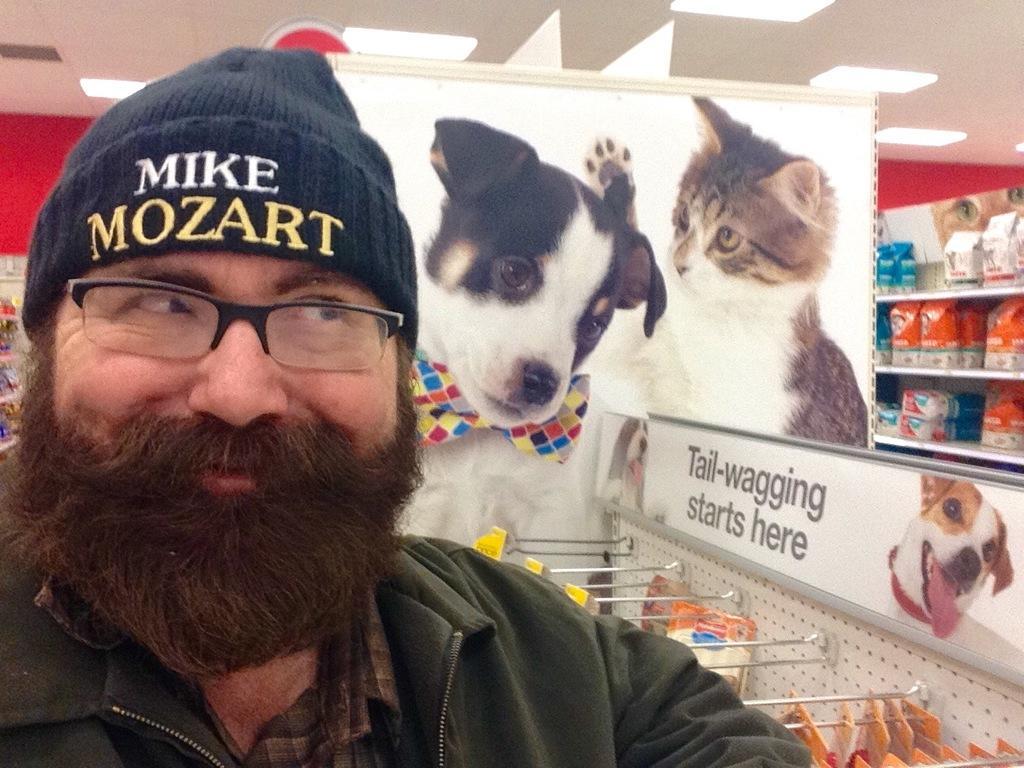In one or two sentences, can you explain what this image depicts? There is a person wearing a cap and specs. On the cap something is written. In the back there is a poster with a dog and cat image. Also there are hangers. On that something is hanged. There are racks. On that some packets are there. On the ceiling there are lights. 